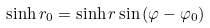Convert formula to latex. <formula><loc_0><loc_0><loc_500><loc_500>\sinh r _ { 0 } = \sinh r \sin \left ( \varphi - \varphi _ { 0 } \right )</formula> 